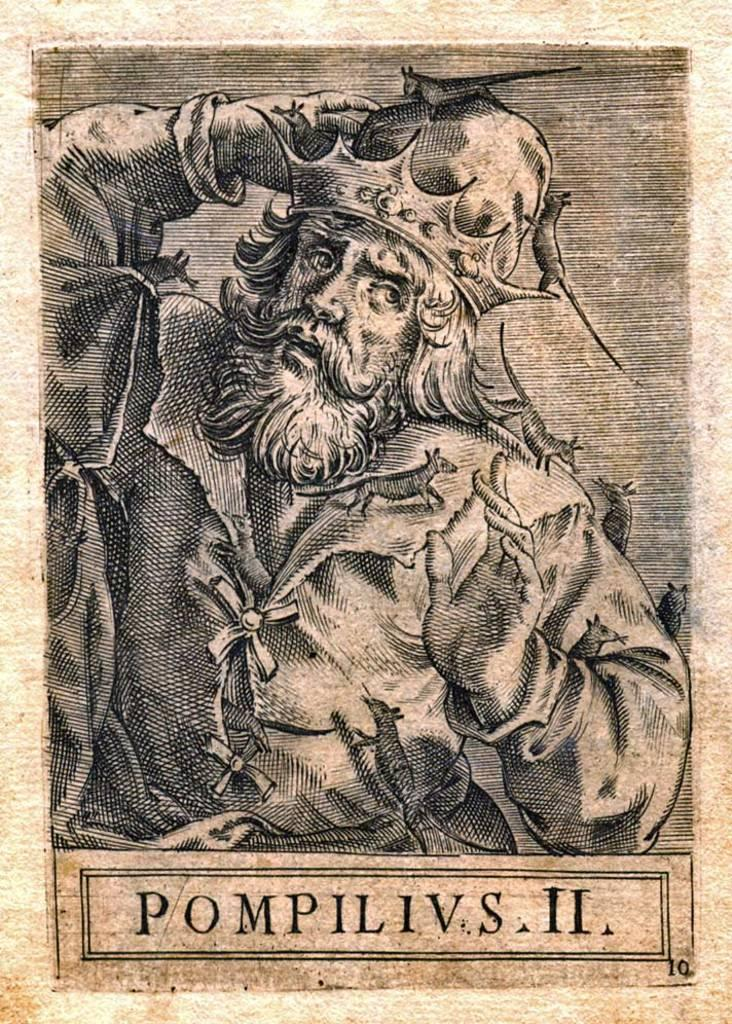<image>
Render a clear and concise summary of the photo. The old black and white picture is the famous Pompilivus II. 